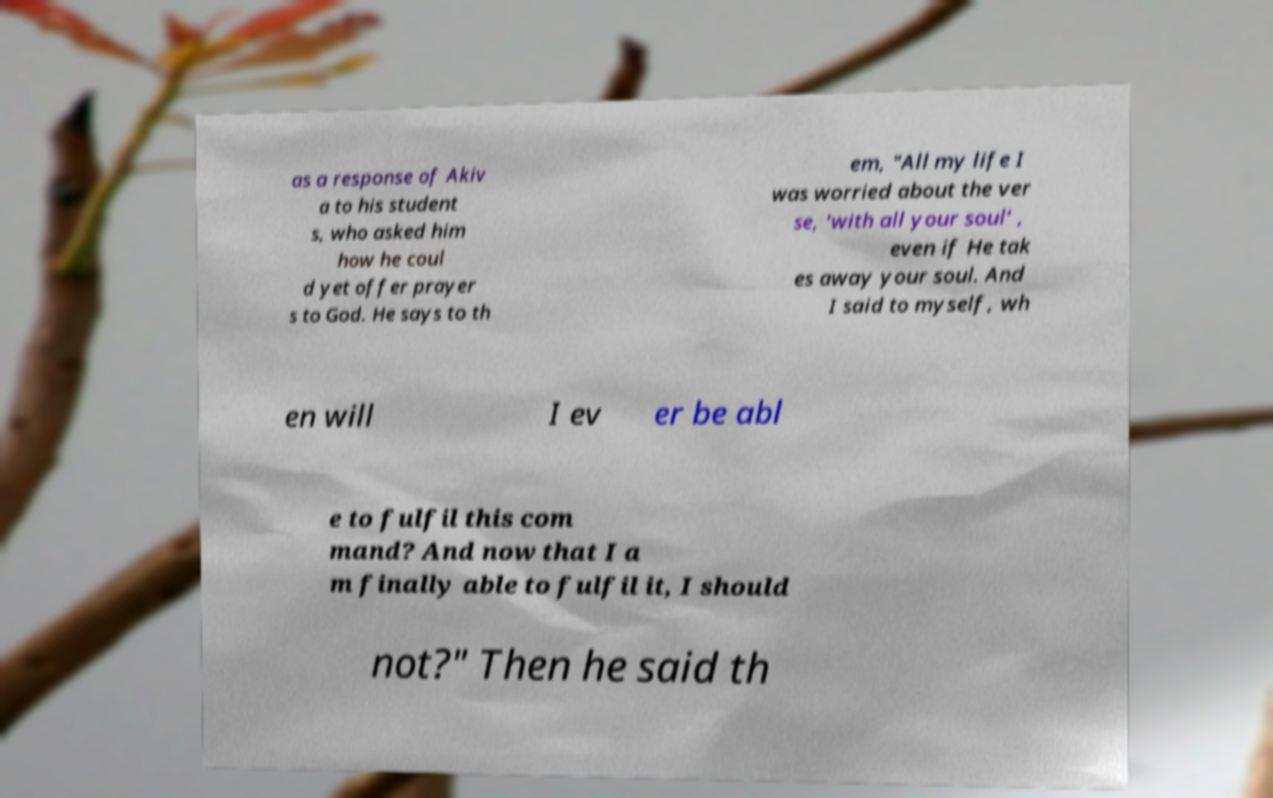For documentation purposes, I need the text within this image transcribed. Could you provide that? as a response of Akiv a to his student s, who asked him how he coul d yet offer prayer s to God. He says to th em, "All my life I was worried about the ver se, 'with all your soul' , even if He tak es away your soul. And I said to myself, wh en will I ev er be abl e to fulfil this com mand? And now that I a m finally able to fulfil it, I should not?" Then he said th 